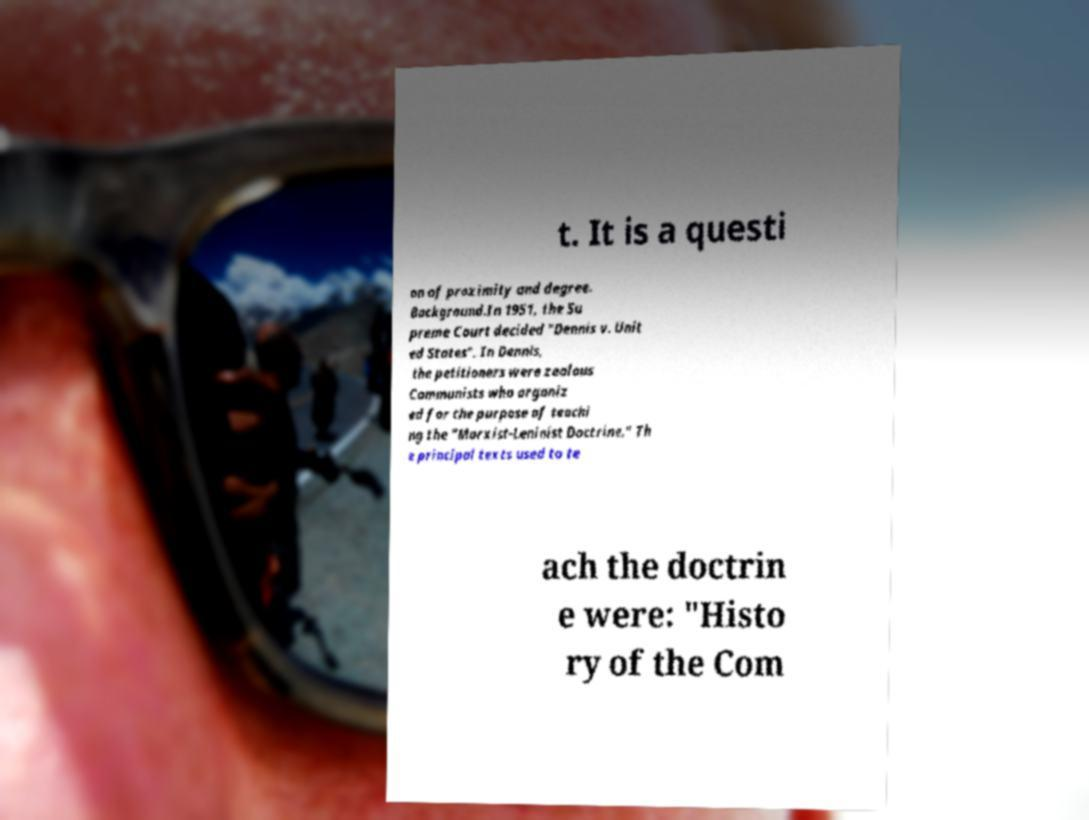Please read and relay the text visible in this image. What does it say? t. It is a questi on of proximity and degree. Background.In 1951, the Su preme Court decided "Dennis v. Unit ed States". In Dennis, the petitioners were zealous Communists who organiz ed for the purpose of teachi ng the "Marxist-Leninist Doctrine." Th e principal texts used to te ach the doctrin e were: "Histo ry of the Com 